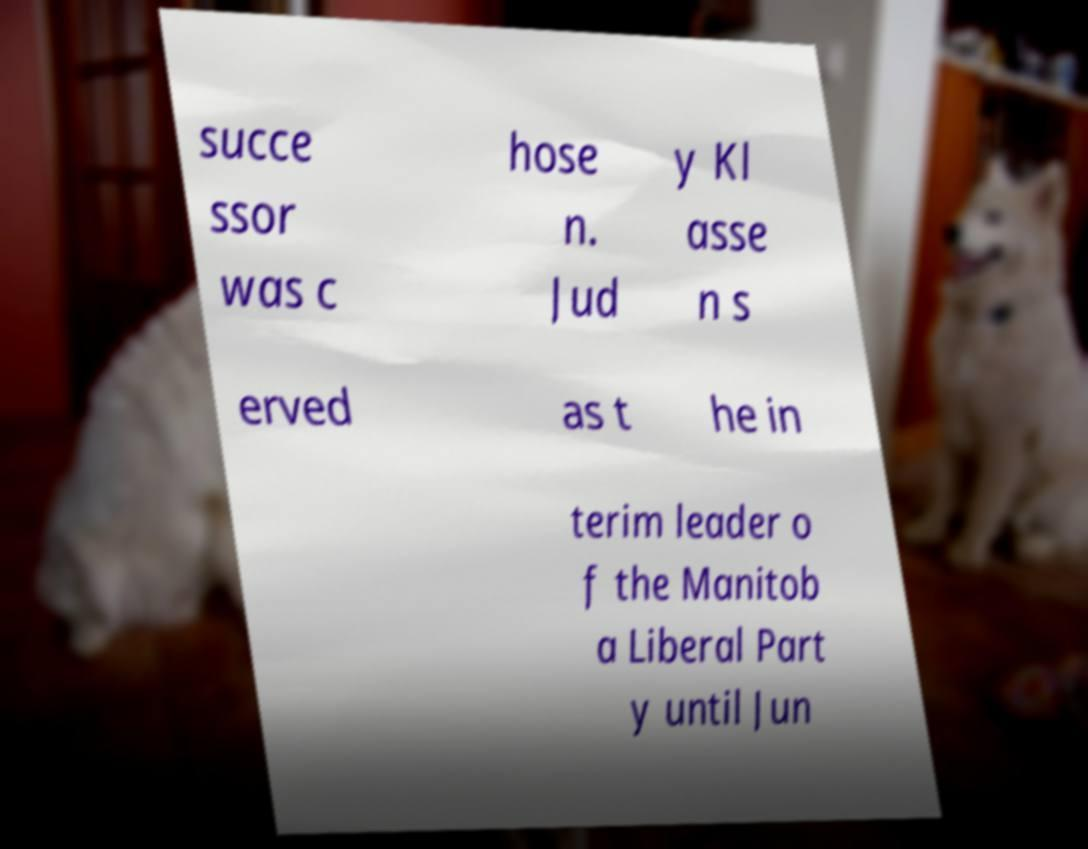Please identify and transcribe the text found in this image. succe ssor was c hose n. Jud y Kl asse n s erved as t he in terim leader o f the Manitob a Liberal Part y until Jun 